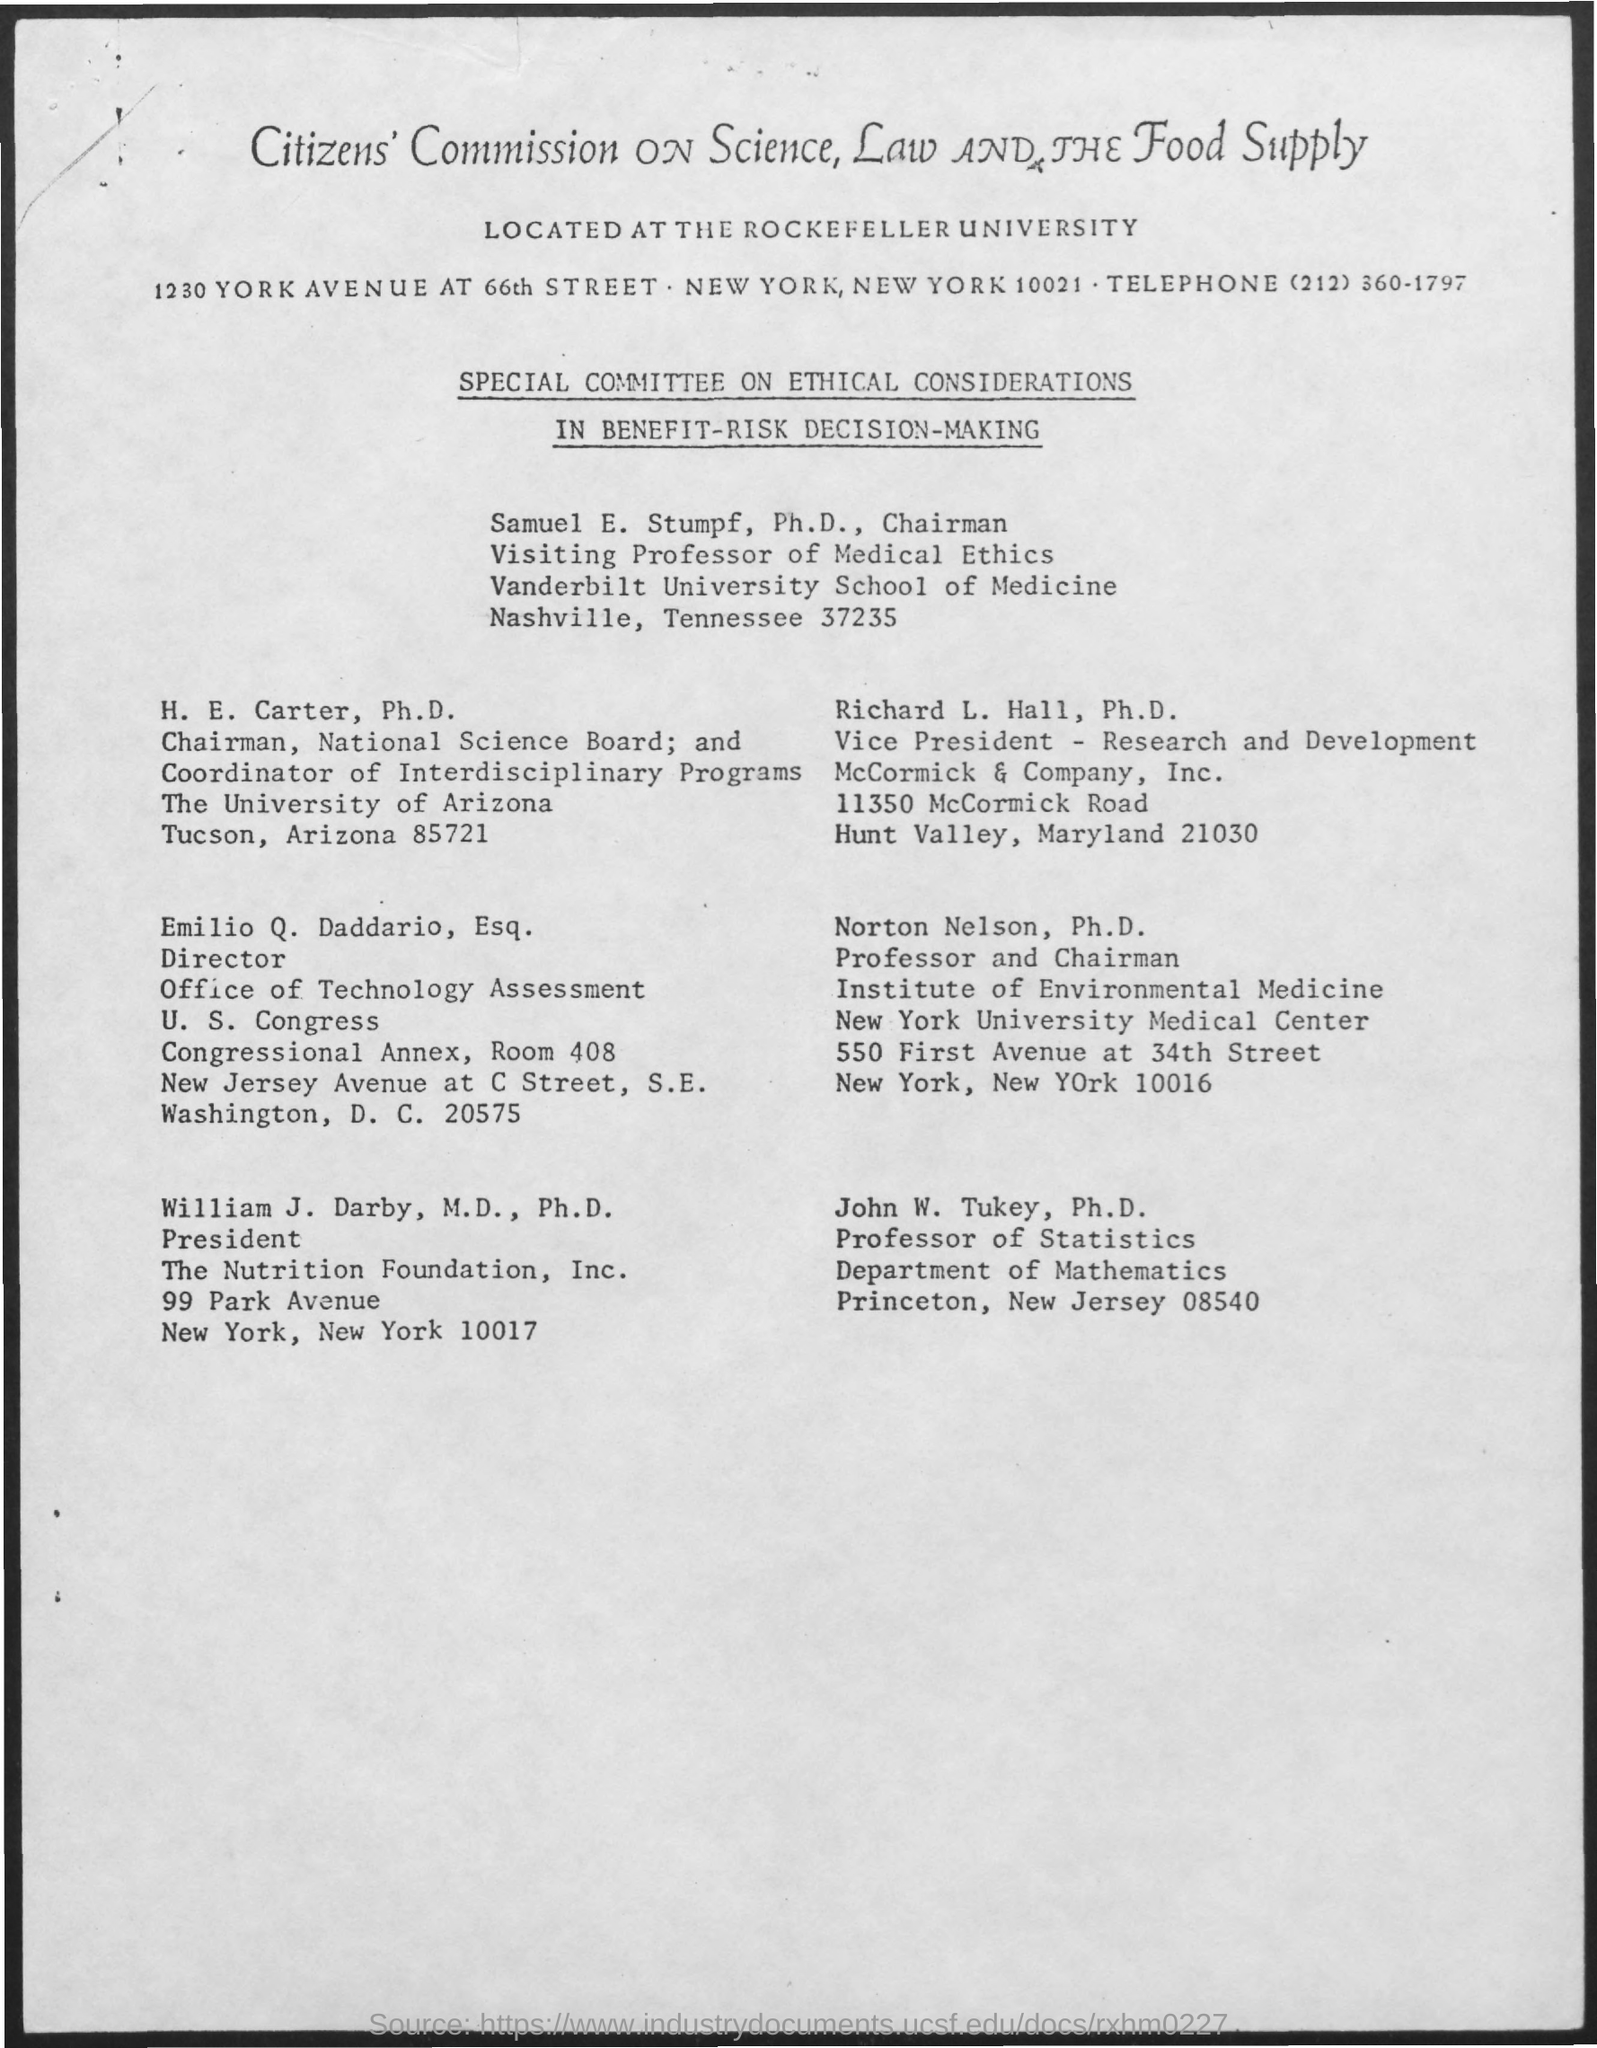What role does the Special Committee on Ethical Considerations in Benefit-Risk Decision-Making play? The Special Committee on Ethical Considerations in Benefit-Risk Decision-Making, as seen on the document, is likely responsible for deliberating and making recommendations regarding the ethical aspects of decisions where benefits and risks to society or individuals are weighed. These decisions are crucial in fields such as medical ethics, environmental policies, and public health. 